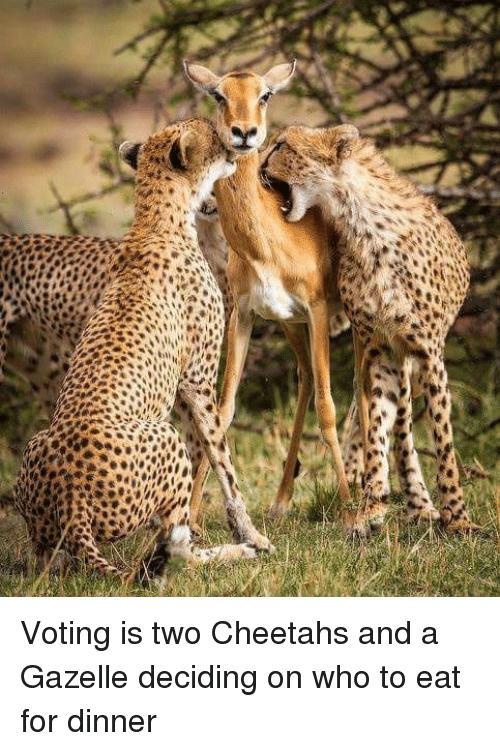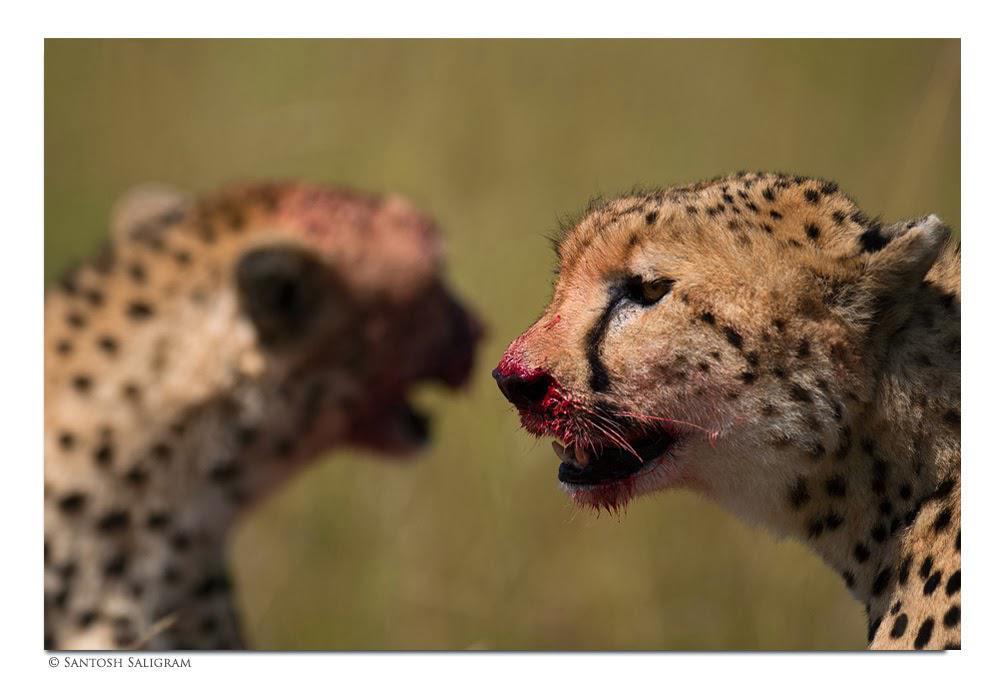The first image is the image on the left, the second image is the image on the right. Evaluate the accuracy of this statement regarding the images: "One image shows only adult cheetahs and the other shows one adult cheetah with two young cheetahs.". Is it true? Answer yes or no. No. The first image is the image on the left, the second image is the image on the right. Analyze the images presented: Is the assertion "One image contains two cheetah kittens and one adult cheetah, and one of the kittens is standing on its hind legs so its head is nearly even with the upright adult cat." valid? Answer yes or no. No. 